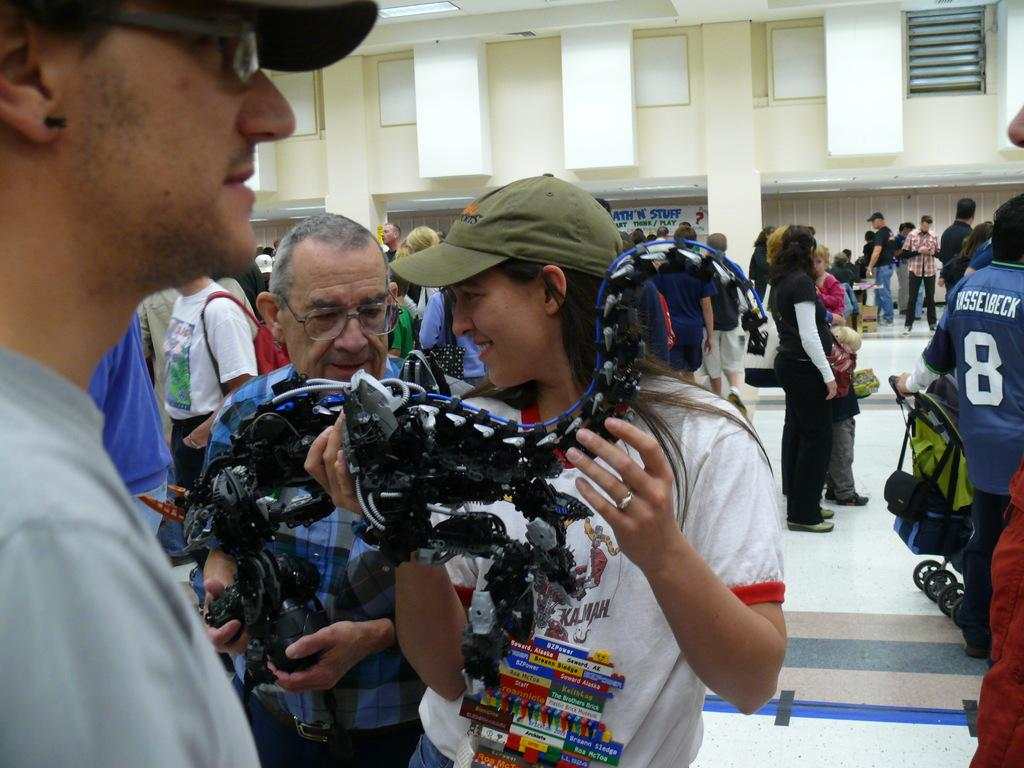What are the two persons in the image doing? The two persons are holding an object in the image. Can you describe the setting in the background of the image? There are other people standing on the floor in the background of the image, and there is a building visible as well. What type of ticket is required to enter the place depicted in the image? There is no mention of a ticket or a specific place in the image, so it is not possible to answer that question. 